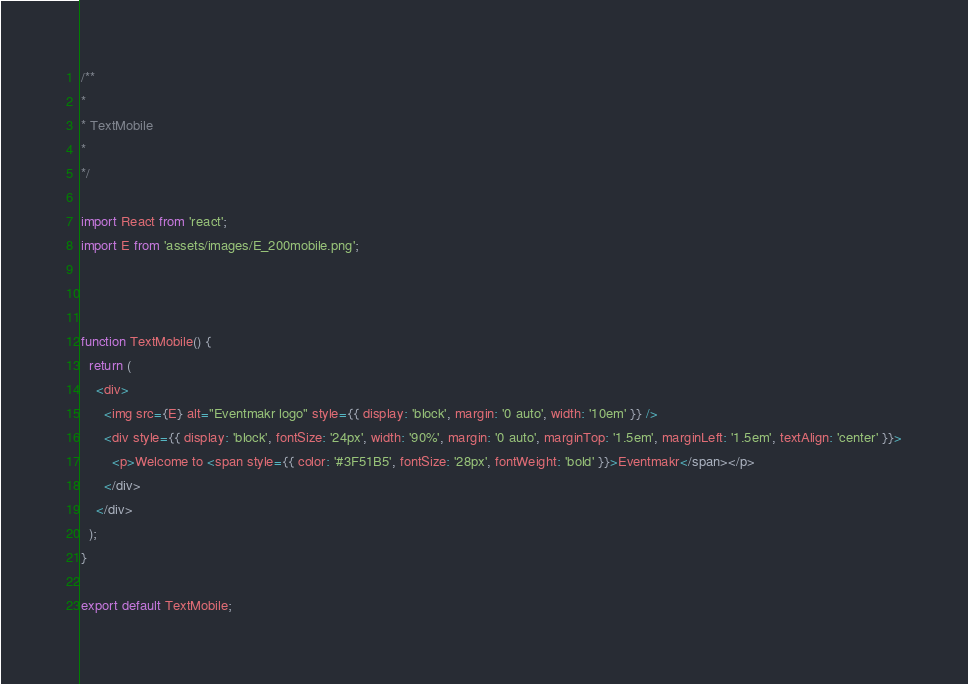Convert code to text. <code><loc_0><loc_0><loc_500><loc_500><_JavaScript_>/**
*
* TextMobile
*
*/

import React from 'react';
import E from 'assets/images/E_200mobile.png';



function TextMobile() {
  return (
    <div>
      <img src={E} alt="Eventmakr logo" style={{ display: 'block', margin: '0 auto', width: '10em' }} />
      <div style={{ display: 'block', fontSize: '24px', width: '90%', margin: '0 auto', marginTop: '1.5em', marginLeft: '1.5em', textAlign: 'center' }}>
        <p>Welcome to <span style={{ color: '#3F51B5', fontSize: '28px', fontWeight: 'bold' }}>Eventmakr</span></p>
      </div>
    </div>
  );
}

export default TextMobile;
</code> 